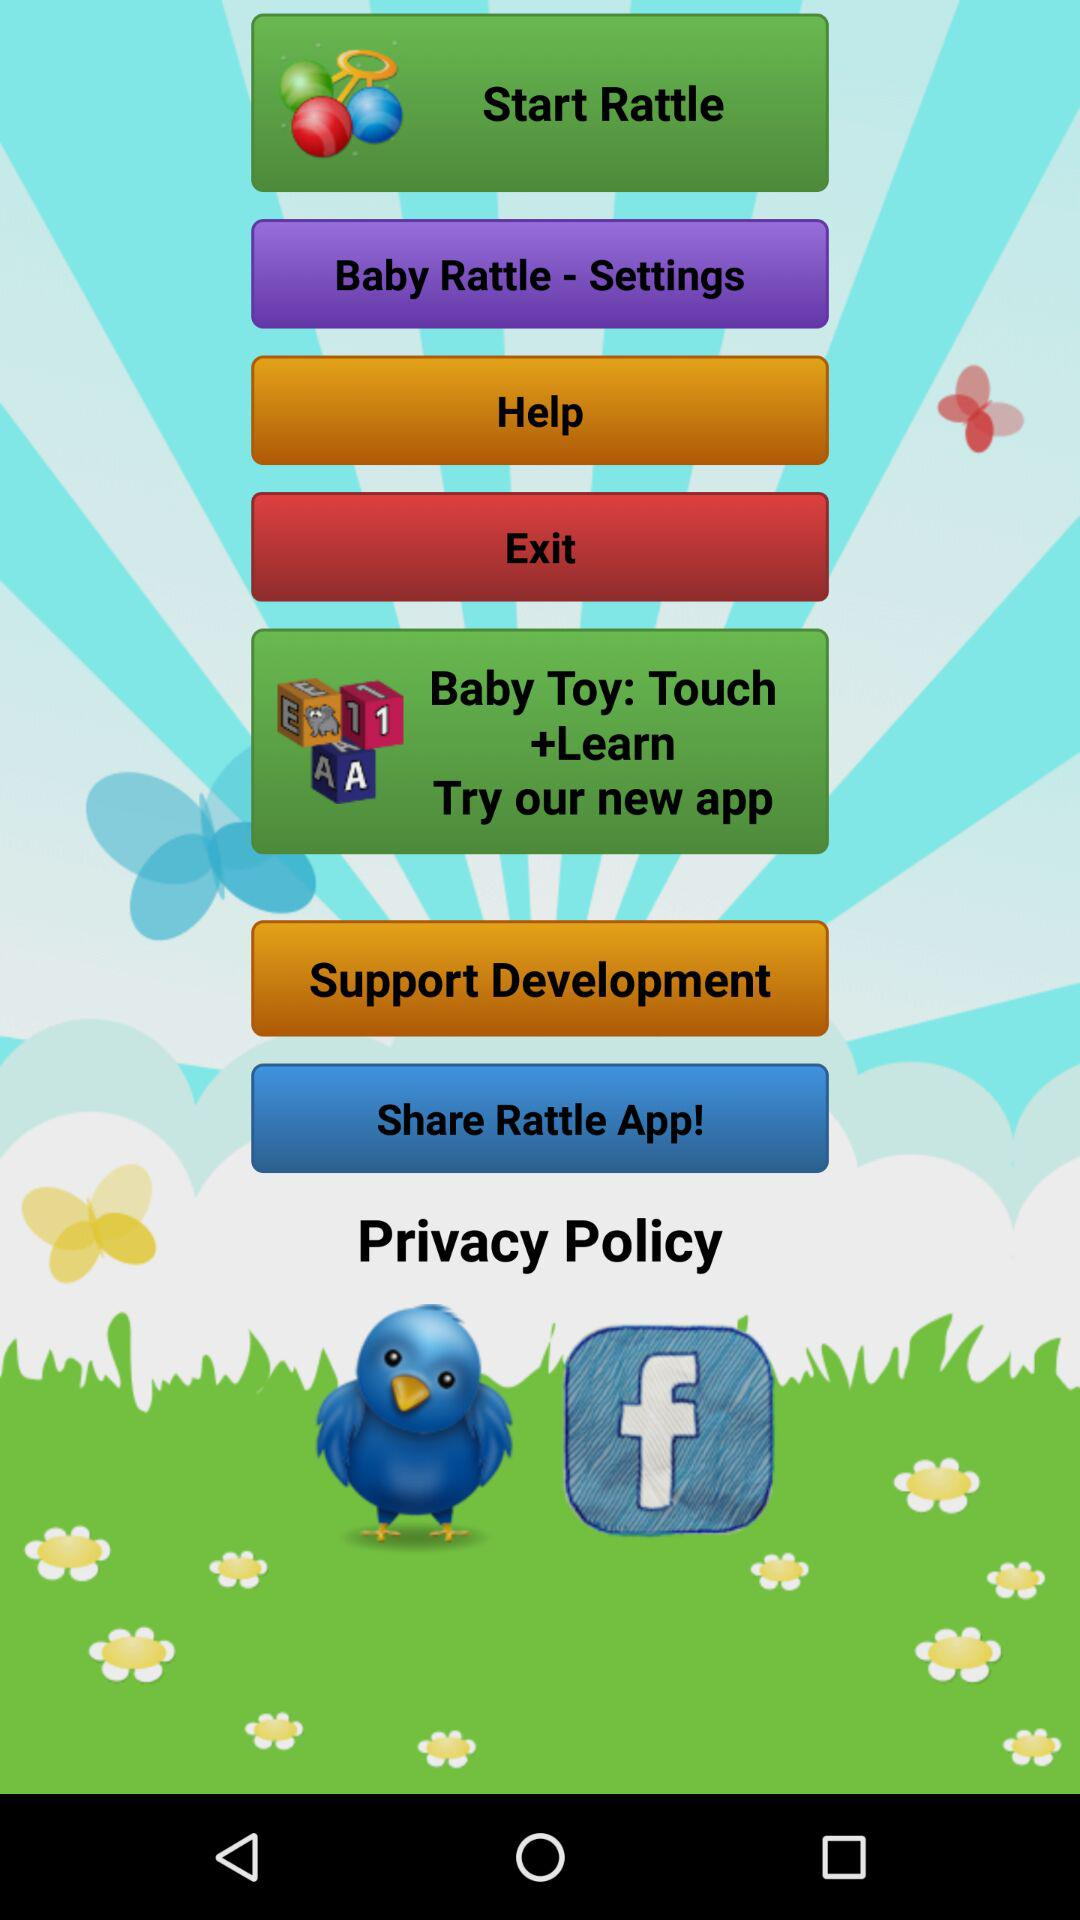Can we share it on facebook?
When the provided information is insufficient, respond with <no answer>. <no answer> 